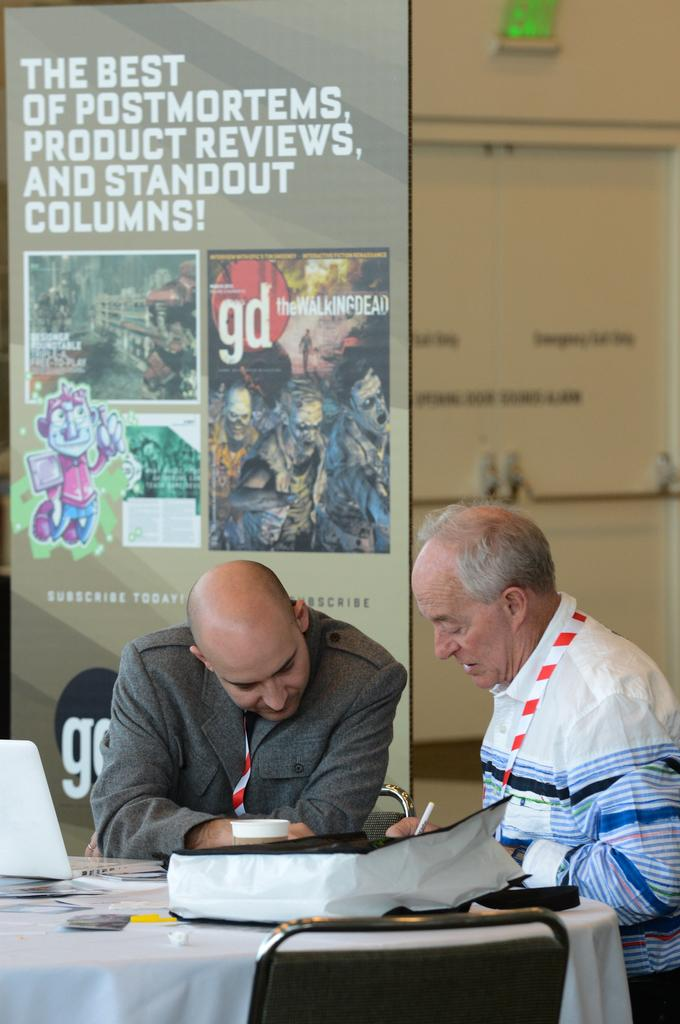<image>
Create a compact narrative representing the image presented. Two people having a meeting in front of a wall that says "The best of Postmortems, product reviews, and standout columns!". 